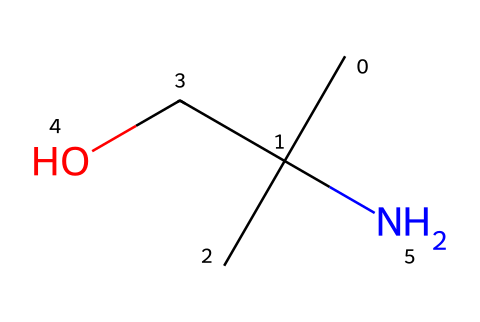What is the molecular formula of this compound? The SMILES representation shows a structure composed of carbon (C), hydrogen (H), nitrogen (N), and oxygen (O) atoms. Counting the atoms based on the SMILES, we find 5 carbons, 13 hydrogens, 1 nitrogen, and 1 oxygen, leading to the molecular formula C5H13NO.
Answer: C5H13NO How many carbon atoms are in this compound? The SMILES representation provides the carbon backbone of this molecule. By examining the notation CC(C)(CO[H]), we count a total of 5 carbon atoms.
Answer: 5 What type of functional group is present in the structure? The presence of -NH2 (an amine) and -OH (a hydroxyl group) indicates the presence of amino and alcohol functional groups in the structure. These groups are recognizable from the nitrogen and oxygen atoms in the SMILES.
Answer: amine and alcohol What is the total number of bonds present in the molecule? In the SMILES, each carbon typically forms four bonds, while nitrogen forms three and oxygen typically forms two. By analyzing how atoms connect, we determine that there are multiple single bonds connecting the atoms in this compound, totaling 7 bonds based on the connections visible in the structure.
Answer: 7 Is this compound classified as polar or nonpolar? The presence of the hydroxyl (-OH) and amine (-NH2) functional groups introduces polar characteristics due to their electronegative atoms (oxygen and nitrogen). The overall structure retains polar traits because of these functional groups, influencing the compound’s solubility in aqueous environments.
Answer: polar Does this compound function as a neurotransmitter? Given that serotonin is known for its role as a neurotransmitter, this molecule represents the precursor in its biosynthetic pathway. The presence of the indole core in serotonin confirms its identity as a neurotransmitter involved in mood regulation.
Answer: yes What role does the nitrogen atom play in this compound? The nitrogen atom in this molecule is part of the amine functional group (-NH2), which is crucial because it can act as a nucleophile in biochemical reactions and helps in binding to receptors in the brain, making it essential for neurotransmission.
Answer: nucleophile 